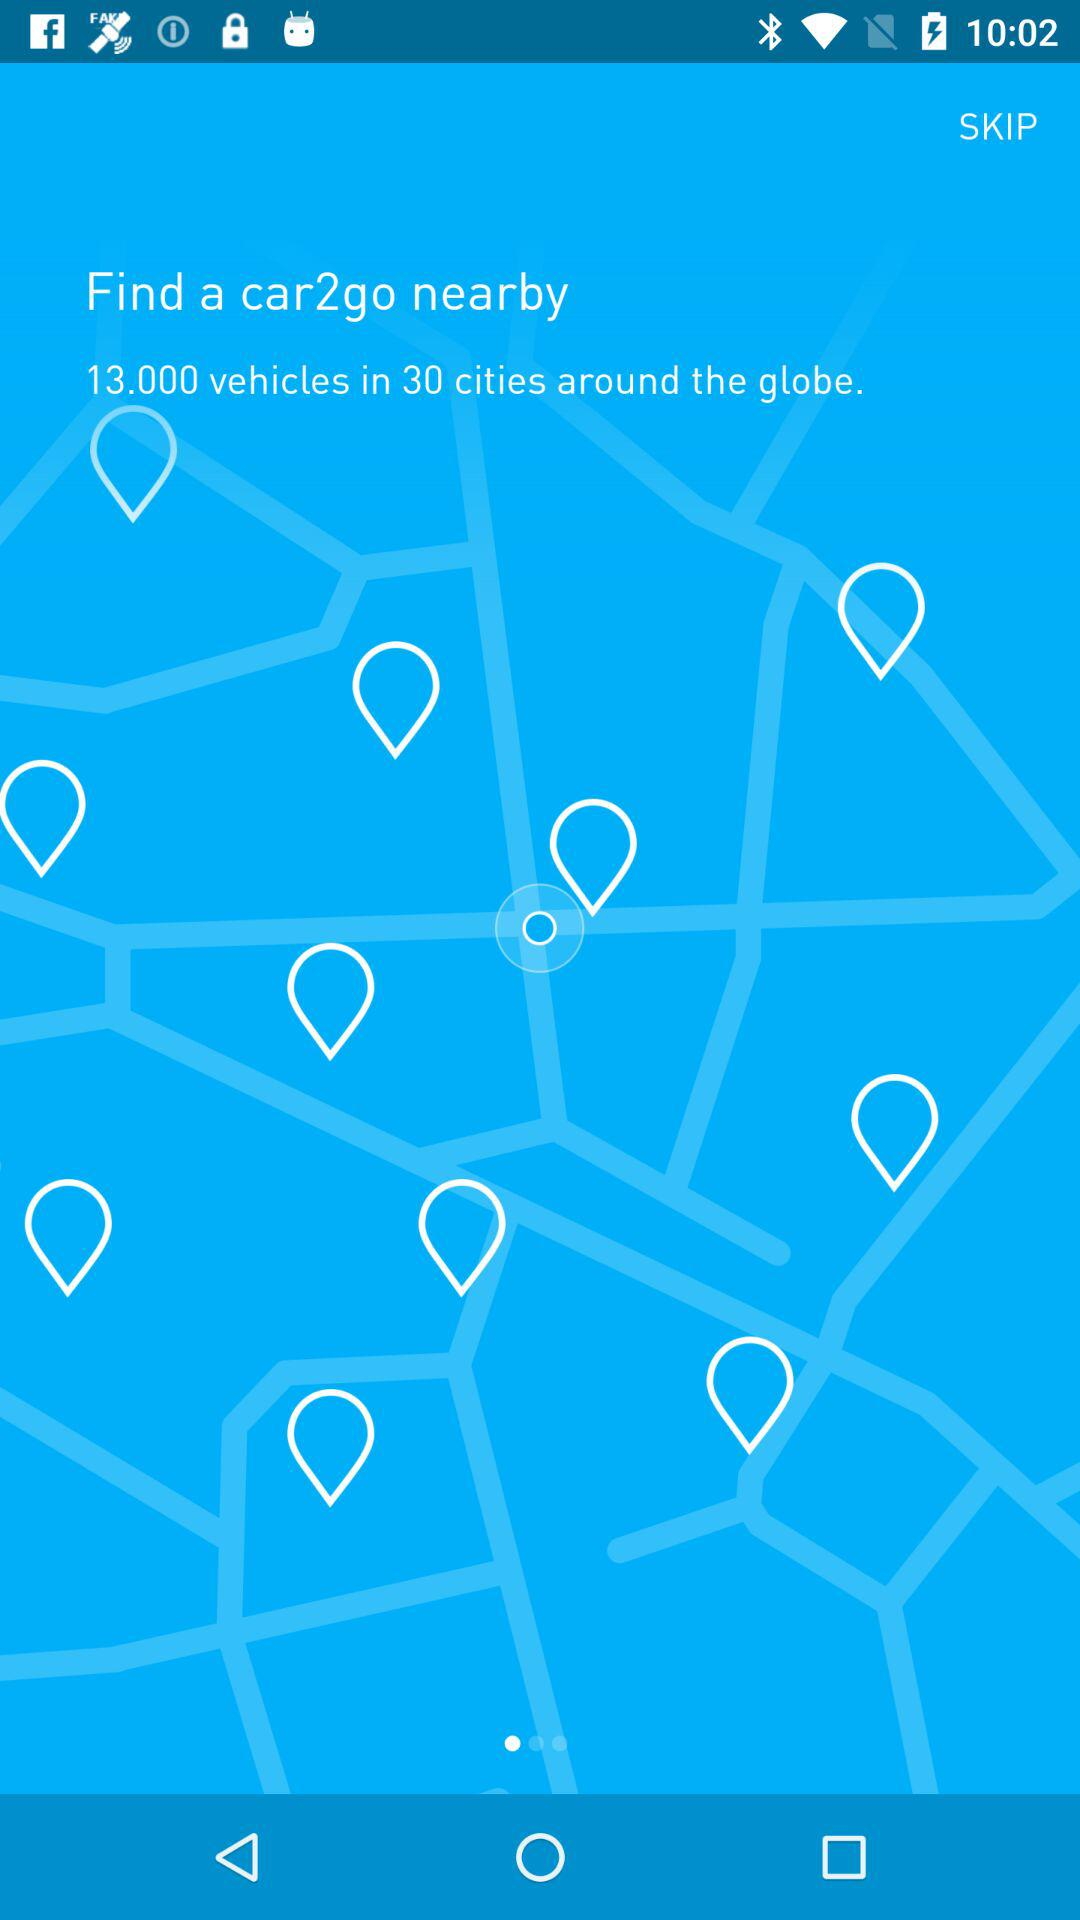Which car is nearby?
When the provided information is insufficient, respond with <no answer>. <no answer> 